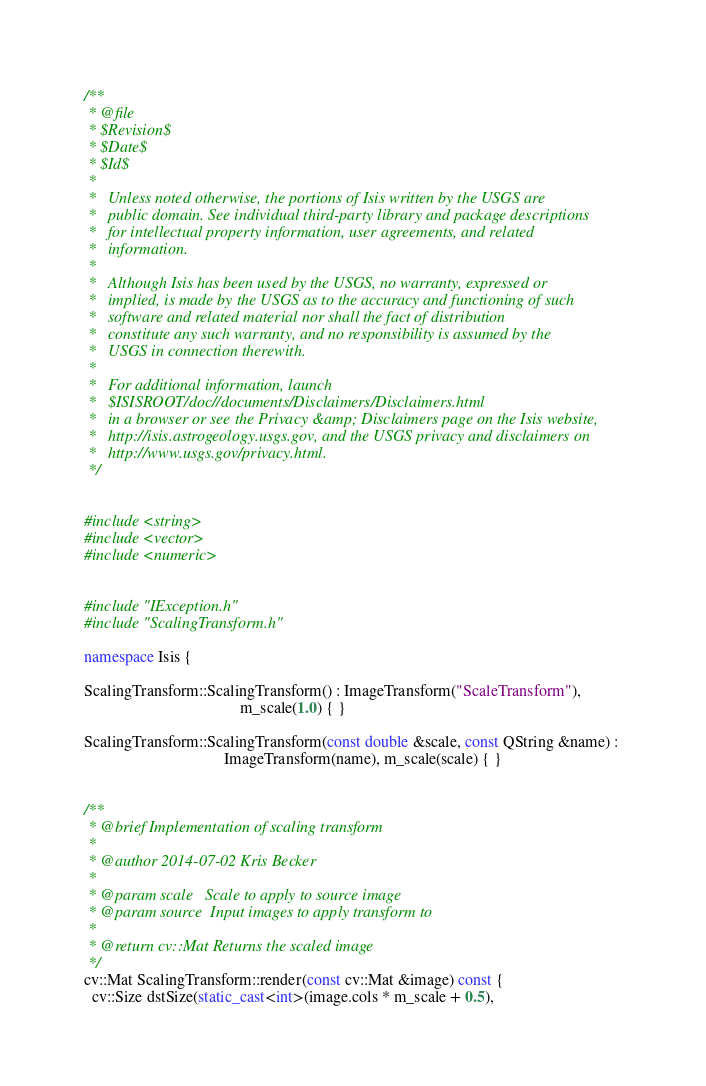<code> <loc_0><loc_0><loc_500><loc_500><_C++_>/**                                                                       
 * @file                                                                  
 * $Revision$
 * $Date$
 * $Id$
 * 
 *   Unless noted otherwise, the portions of Isis written by the USGS are 
 *   public domain. See individual third-party library and package descriptions 
 *   for intellectual property information, user agreements, and related  
 *   information.                                                         
 *                                                                        
 *   Although Isis has been used by the USGS, no warranty, expressed or   
 *   implied, is made by the USGS as to the accuracy and functioning of such 
 *   software and related material nor shall the fact of distribution     
 *   constitute any such warranty, and no responsibility is assumed by the
 *   USGS in connection therewith.                                        
 *                                                                        
 *   For additional information, launch                                   
 *   $ISISROOT/doc//documents/Disclaimers/Disclaimers.html                
 *   in a browser or see the Privacy &amp; Disclaimers page on the Isis website,
 *   http://isis.astrogeology.usgs.gov, and the USGS privacy and disclaimers on
 *   http://www.usgs.gov/privacy.html.                                    
 */ 


#include <string>
#include <vector>
#include <numeric>


#include "IException.h"
#include "ScalingTransform.h"

namespace Isis {

ScalingTransform::ScalingTransform() : ImageTransform("ScaleTransform"), 
                                       m_scale(1.0) { }

ScalingTransform::ScalingTransform(const double &scale, const QString &name) : 
                                   ImageTransform(name), m_scale(scale) { }
                                                  

/**
 * @brief Implementation of scaling transform
 *  
 * @author 2014-07-02 Kris Becker
 * 
 * @param scale   Scale to apply to source image
 * @param source  Input images to apply transform to
 * 
 * @return cv::Mat Returns the scaled image
 */
cv::Mat ScalingTransform::render(const cv::Mat &image) const {
  cv::Size dstSize(static_cast<int>(image.cols * m_scale + 0.5), </code> 